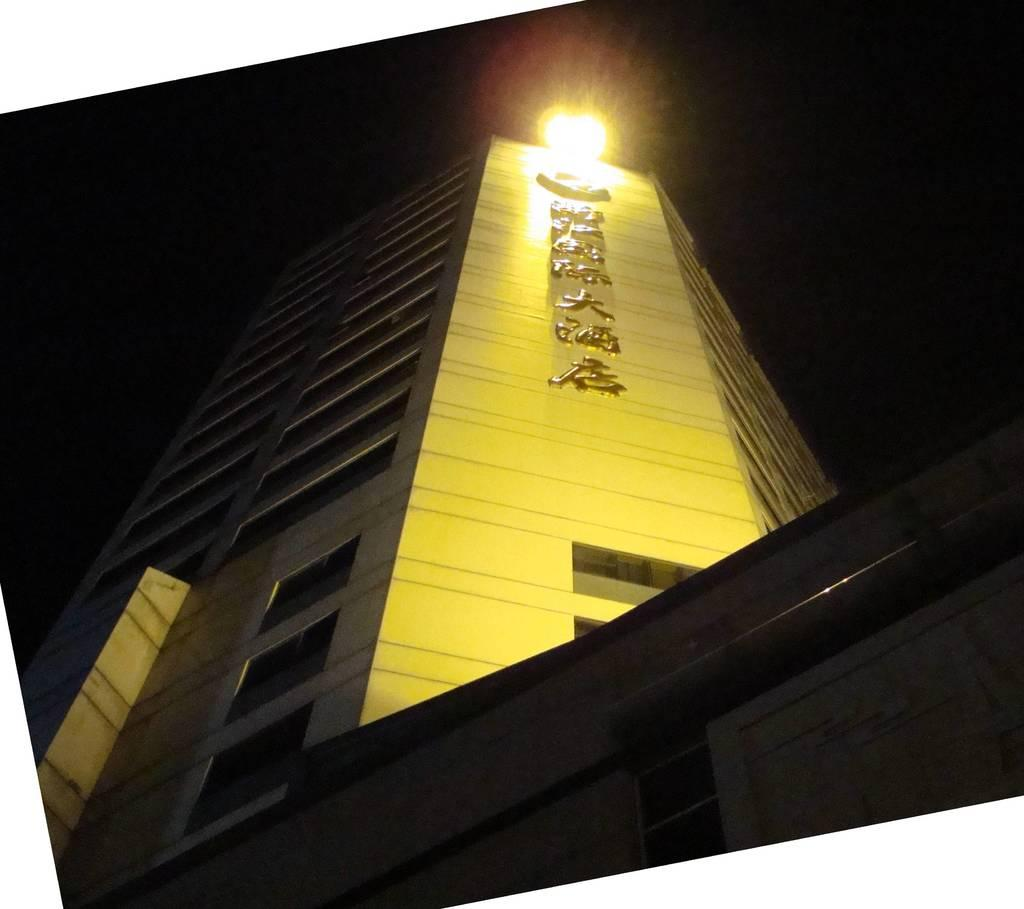What structure is the main subject of the image? There is a building in the image. What can be observed about the background of the image? The background of the image is dark. How many rules are being followed by the babies in the image? There are no babies present in the image, so it is not possible to determine how many rules they might be following. 